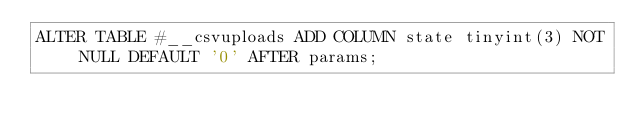<code> <loc_0><loc_0><loc_500><loc_500><_SQL_>ALTER TABLE #__csvuploads ADD COLUMN state tinyint(3) NOT NULL DEFAULT '0' AFTER params;</code> 